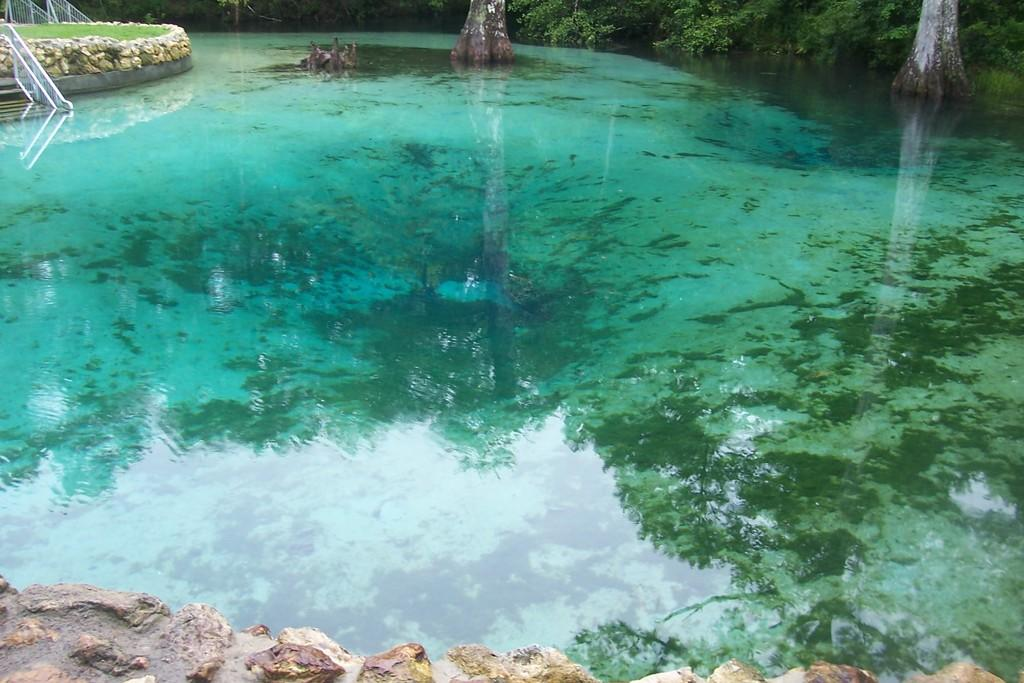What is the main feature in the center of the image? There is a pond in the center of the image. What can be seen in the background of the image? There are trees, a railing, and grass in the background of the image. What is at the bottom of the image? There is a wall at the bottom of the image. Where is the scarecrow standing in the image? There is no scarecrow present in the image. What type of bat is flying over the pond in the image? There are no bats present in the image; it features a pond, trees, a railing, grass, and a wall. 